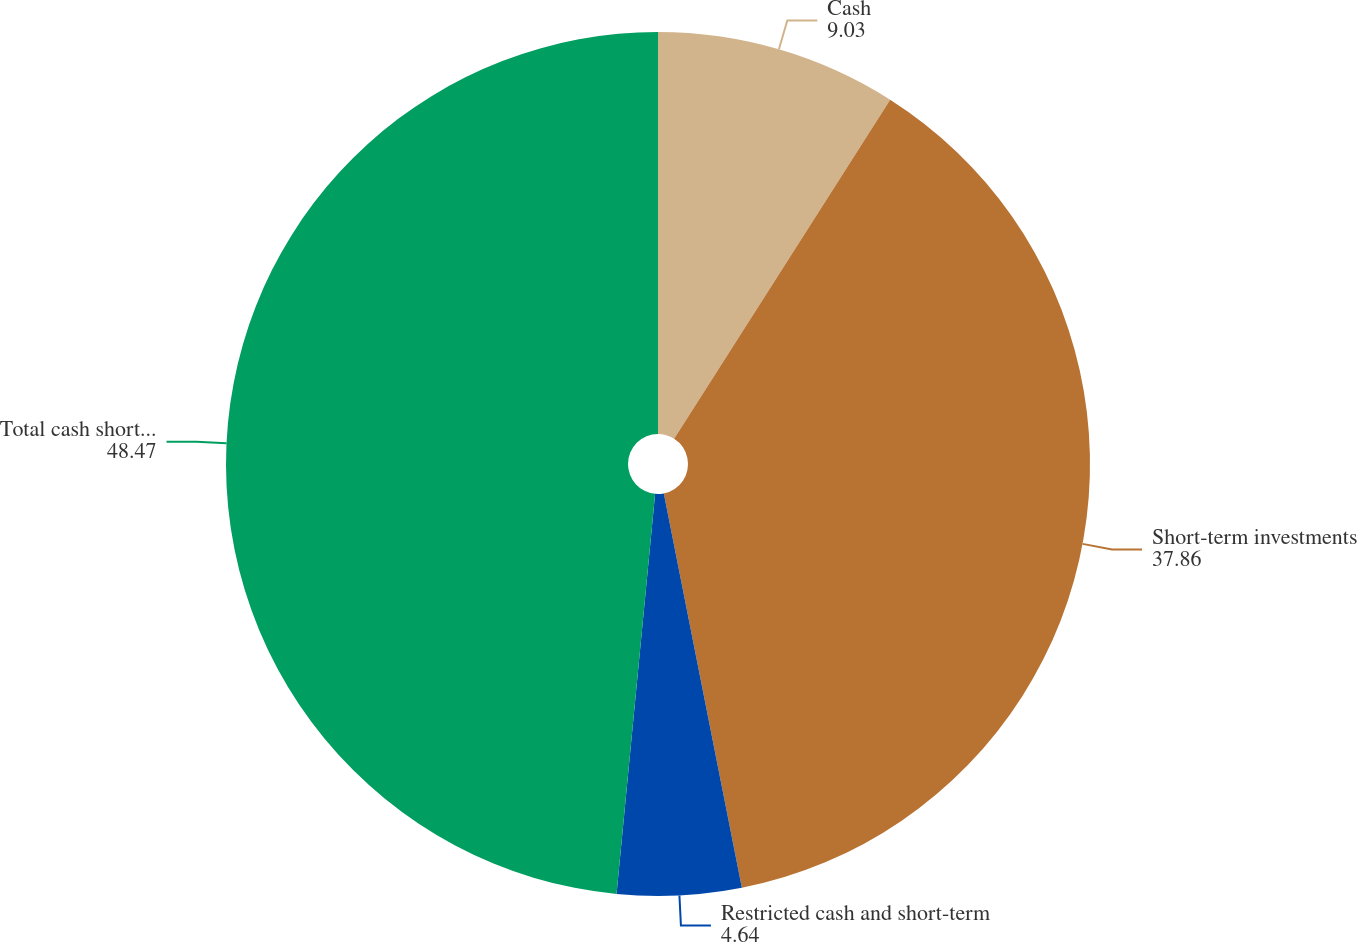<chart> <loc_0><loc_0><loc_500><loc_500><pie_chart><fcel>Cash<fcel>Short-term investments<fcel>Restricted cash and short-term<fcel>Total cash short-term<nl><fcel>9.03%<fcel>37.86%<fcel>4.64%<fcel>48.47%<nl></chart> 